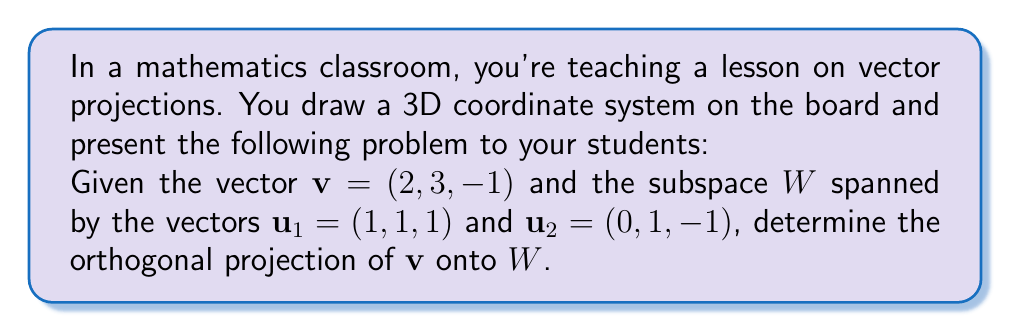Help me with this question. To find the orthogonal projection of $\mathbf{v}$ onto $W$, we'll follow these steps:

1) First, we need to find an orthonormal basis for $W$. We can use the Gram-Schmidt process:

   $\mathbf{e}_1 = \frac{\mathbf{u}_1}{\|\mathbf{u}_1\|} = \frac{(1,1,1)}{\sqrt{3}}$
   
   $\mathbf{u}_2' = \mathbf{u}_2 - (\mathbf{u}_2 \cdot \mathbf{e}_1)\mathbf{e}_1 = (0,1,-1) - (0 \cdot \frac{1}{\sqrt{3}} + 1 \cdot \frac{1}{\sqrt{3}} - 1 \cdot \frac{1}{\sqrt{3}})(\frac{1}{\sqrt{3}},\frac{1}{\sqrt{3}},\frac{1}{\sqrt{3}}) = (0,1,-1)$
   
   $\mathbf{e}_2 = \frac{\mathbf{u}_2'}{\|\mathbf{u}_2'\|} = \frac{(0,1,-1)}{\sqrt{2}}$

2) Now, we have an orthonormal basis $\{\mathbf{e}_1, \mathbf{e}_2\}$ for $W$.

3) The projection of $\mathbf{v}$ onto $W$ is given by:

   $\text{proj}_W(\mathbf{v}) = (\mathbf{v} \cdot \mathbf{e}_1)\mathbf{e}_1 + (\mathbf{v} \cdot \mathbf{e}_2)\mathbf{e}_2$

4) Let's calculate the dot products:

   $\mathbf{v} \cdot \mathbf{e}_1 = (2,3,-1) \cdot (\frac{1}{\sqrt{3}},\frac{1}{\sqrt{3}},\frac{1}{\sqrt{3}}) = \frac{2+3-1}{\sqrt{3}} = \frac{4}{\sqrt{3}}$
   
   $\mathbf{v} \cdot \mathbf{e}_2 = (2,3,-1) \cdot (0,\frac{1}{\sqrt{2}},-\frac{1}{\sqrt{2}}) = \frac{3+1}{\sqrt{2}} = \frac{4}{\sqrt{2}}$

5) Now, we can compute the projection:

   $\text{proj}_W(\mathbf{v}) = \frac{4}{\sqrt{3}}(\frac{1}{\sqrt{3}},\frac{1}{\sqrt{3}},\frac{1}{\sqrt{3}}) + \frac{4}{\sqrt{2}}(0,\frac{1}{\sqrt{2}},-\frac{1}{\sqrt{2}})$
   
   $= (\frac{4}{3},\frac{4}{3},\frac{4}{3}) + (0,2,-2)$
   
   $= (\frac{4}{3},\frac{10}{3},-\frac{2}{3})$
Answer: $(\frac{4}{3},\frac{10}{3},-\frac{2}{3})$ 